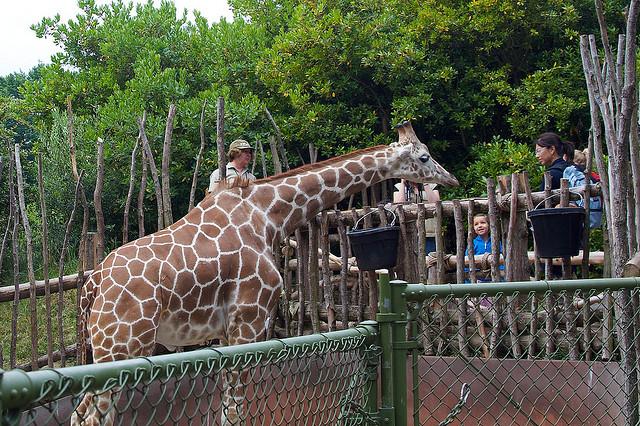How many people are pictured here?
Concise answer only. 3. Which baby is smiling?
Give a very brief answer. Human. Is the giraffe fully enclosed?
Concise answer only. Yes. 